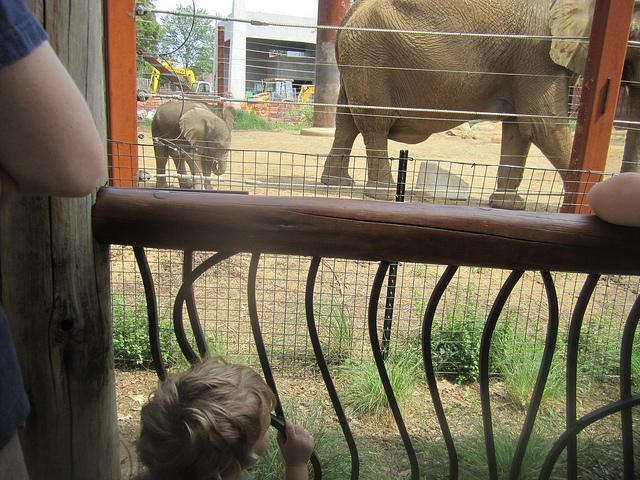How many elephants are there?
Give a very brief answer. 2. How many people are in the picture?
Give a very brief answer. 3. How many kids are holding a laptop on their lap ?
Give a very brief answer. 0. 